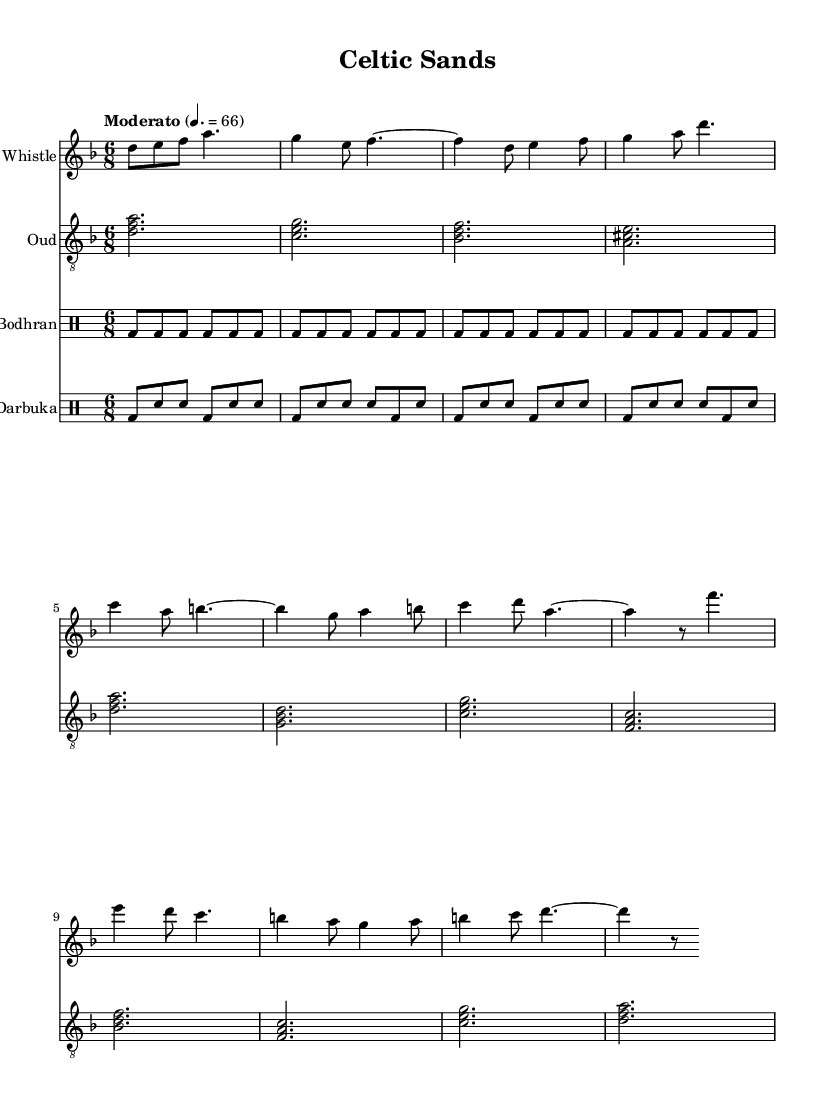What is the key signature of this music? The key signature in the sheet music is indicated by the number of sharps or flats before the notes. Here, there are no sharps or flats displayed, which identifies it as D minor.
Answer: D minor What is the time signature of this composition? The time signature is presented at the beginning of the score, showing how many beats are in each measure. Here, it is 6/8, meaning there are six eighth notes per measure.
Answer: 6/8 What is the tempo marking of this piece? The tempo marking informs the performer about the speed of the piece, given in beats per minute or a descriptive term. In this score, it states "Moderato" and gives a metronome mark of 66 beats per minute.
Answer: Moderato 66 How many instruments are featured in this score? The number of staves in the score indicates how many instruments are present. In this case, there are four distinct staves labeled for the tin whistle, oud, bodhran, and darbuka.
Answer: Four Which instrument plays the melody in the intro section? The melody in the intro section is primarily carried by the tin whistle, as the corresponding notes suggest it leads the musical theme.
Answer: Tin Whistle What is the primary function of the bodhran and darbuka in this composition? The bodhran and darbuka are percussion instruments adding rhythmic support. They serve to maintain the tempo and enhance the rhythmic feel typical of both Celtic and Middle Eastern music.
Answer: Rhythmic support What is the musical genre of this piece? The fusion of Celtic melodies with Middle Eastern instruments aligns it under the umbrella of World Music, which celebrates diverse cultural influences and musical traditions.
Answer: World Music 